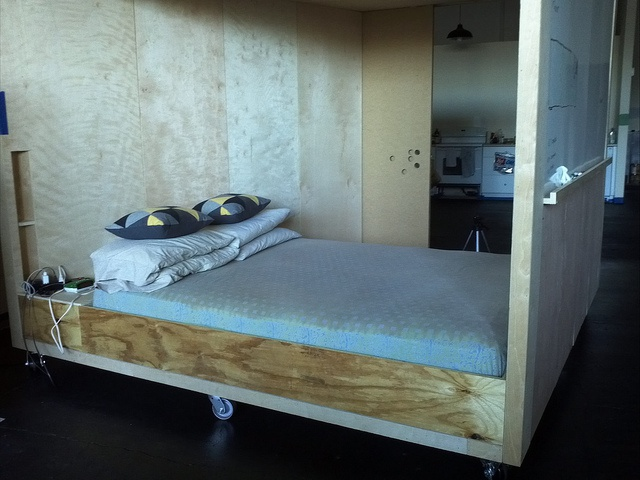Describe the objects in this image and their specific colors. I can see bed in darkgray, gray, and lightblue tones, oven in darkgray, black, blue, and darkblue tones, and clock in darkgray, black, darkblue, blue, and gray tones in this image. 